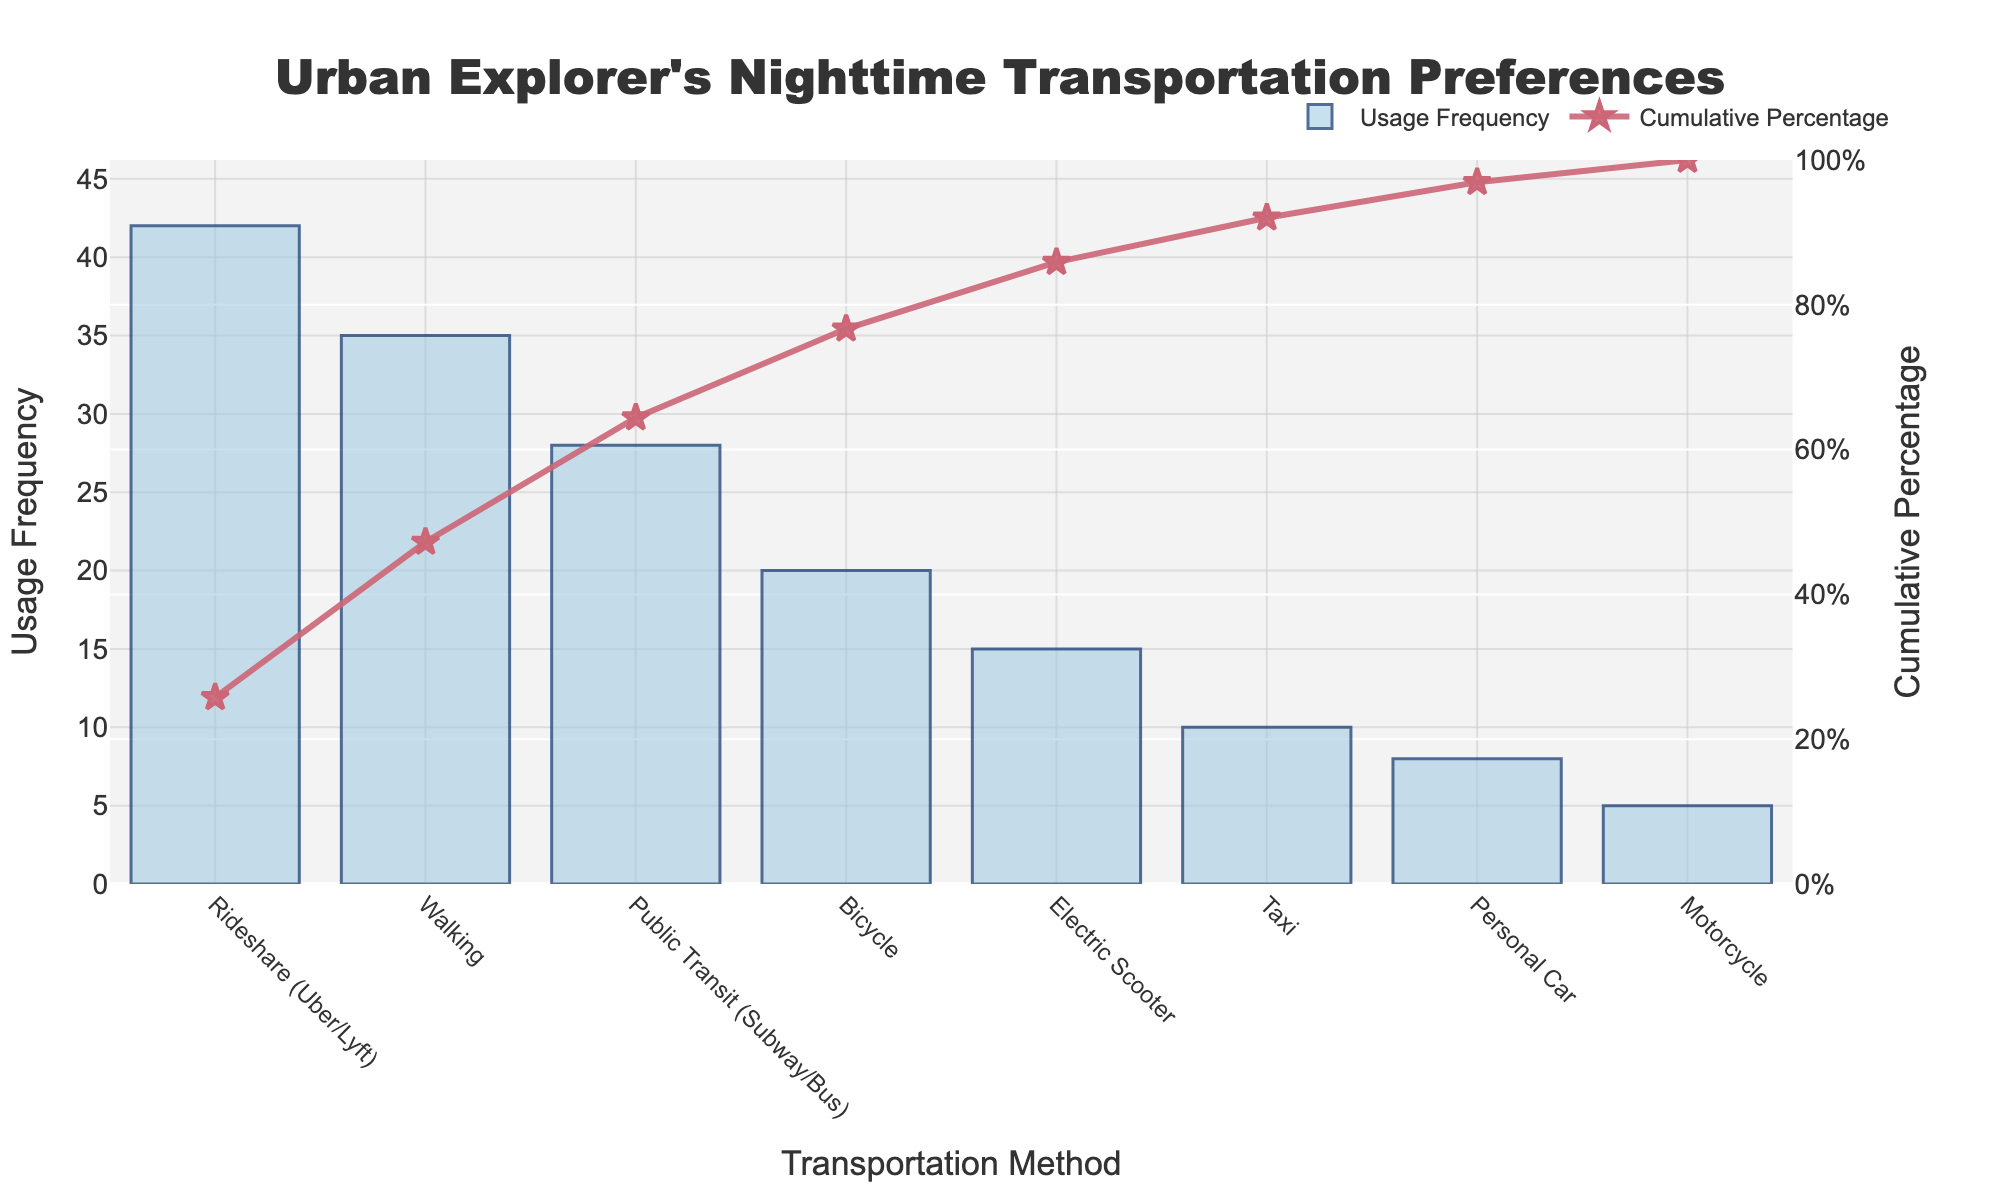How many transportation methods are listed in the chart? The chart shows the preferred nighttime transportation methods along the x-axis, and counting the unique entries will give the total number of methods.
Answer: 8 What is the most frequently used transportation method? The method with the highest bar signifies the most frequent usage. In this case, it is labeled as "Rideshare (Uber/Lyft)" with a frequency of 42.
Answer: Rideshare (Uber/Lyft) Which transportation method has a cumulative percentage of around 50%? The cumulative percentage line intersects the 50% mark approximately between the values of "Walking" and "Public Transit." Checking the values, "Walking" has the closest cumulative percentage to 50%
Answer: Walking How much higher is the usage frequency of Rideshare compared to Personal Car? The usage frequency of Rideshare is 42 and Personal Car is 8. The difference is calculated as 42 - 8.
Answer: 34 Which transportation methods make up the top 80% of cumulative usage? By following the cumulative percentage line, we can see that the methods "Rideshare," "Walking," "Public Transit," and "Bicycle" cumulatively account for over 80%.
Answer: Rideshare, Walking, Public Transit, Bicycle Which method has the least usage frequency? From the bar chart, the shortest bar represents the least usage frequency, which corresponds to "Motorcycle" with a frequency of 5.
Answer: Motorcycle What is the cumulative percentage for Public Transit? The cumulative percentage can be read from the line graph where "Public Transit" intersects. According to the chart, Public Transit ends at about 75%.
Answer: 75% How much does the sum of the two least frequently used methods contribute to the total usage? The least frequently used methods are "Motorcycle" and "Personal Car" with frequencies of 5 and 8 respectively. Their sum is 5 + 8.
Answer: 13 Which transportation method is used more often, Bicycle or Electric Scooter? Compare the height of the bars for Bicycle and Electric Scooter. Bicycle has a higher usage frequency of 20 compared to Electric Scooter's 15.
Answer: Bicycle What is the cumulative percentage after adding Bicycle's usage frequency? The figures show that the cumulative percentage after "Bicycle" is approximately 80%.
Answer: 80% 